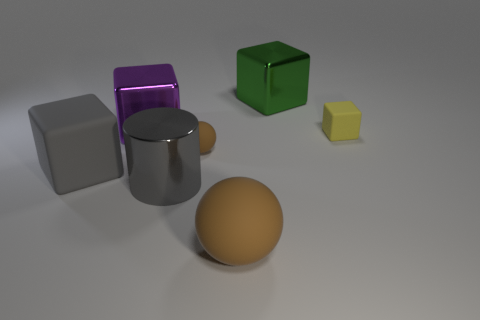Add 2 big yellow shiny balls. How many objects exist? 9 Subtract all blocks. How many objects are left? 3 Add 1 green things. How many green things are left? 2 Add 6 large metallic things. How many large metallic things exist? 9 Subtract 0 cyan spheres. How many objects are left? 7 Subtract all tiny brown rubber balls. Subtract all big purple metallic blocks. How many objects are left? 5 